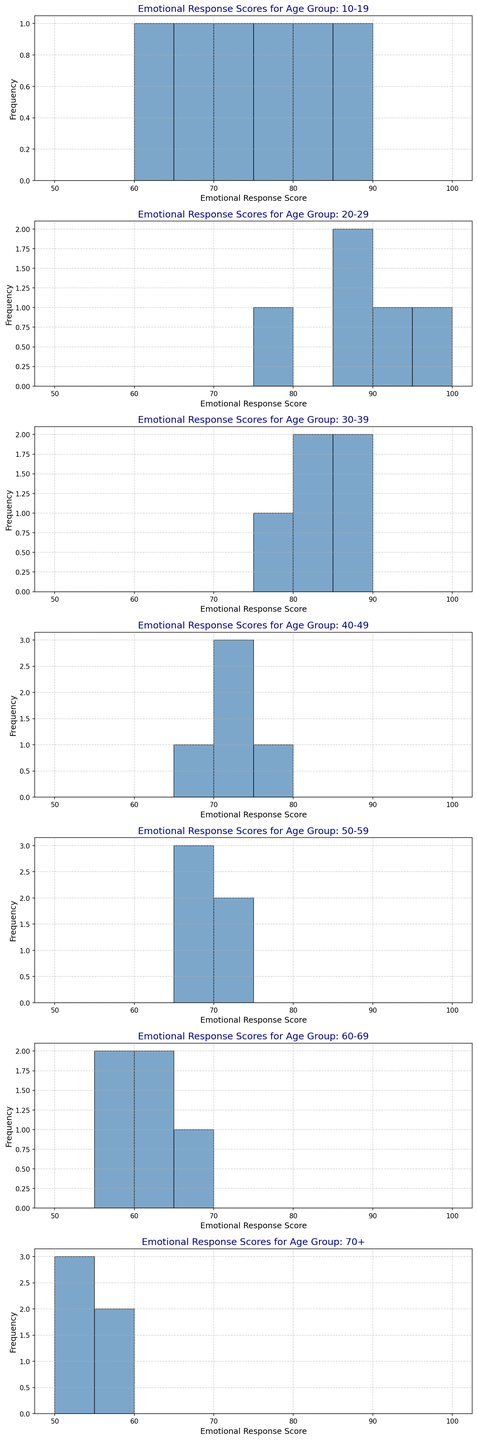Can you identify which age group has the highest peak in their histogram? Looking at the histograms, the age group 20-29 has the highest peak in frequency.
Answer: 20-29 How many age groups have their histogram peaks between the emotional response scores of 70 and 80? Checking each histogram, the age groups 10-19, 30-39, and 40-49 have their peaks between the scores of 70 and 80.
Answer: 3 Which age group shows the broadest distribution of emotional response scores in their histogram? By visual inspection, the age group 60-69 shows scores ranging from 55 to 65, which is a relatively broad range compared to others.
Answer: 60-69 For the 40-49 age group, what is the frequency of the most common emotional response score? The histogram for 40-49 shows the highest bar at the score of 72, with a frequency of more than 70.
Answer: 72 Compare the emotional response scores' concentration for the age groups 50-59 and 70+. Which group has a more spread-out score distribution? The histogram for the 50-59 group shows scores concentrated between 65 and 72, while the 70+ group shows a spread between 50 and 57. Thus, 70+ has a more spread-out distribution.
Answer: 70+ What can you deduce regarding the emotional response scores of age group 10-19 from its histogram shape? The histogram for 10-19 is relatively broad with frequencies dispersed mostly around 65, 70, 75, suggesting a wider variation in emotional responses within this group.
Answer: Wider Variation Are there any age groups where none of the emotional response scores fall below 65? Checking the histograms, the age groups 20-29 and 30-39 have no scores below 65.
Answer: 2 What is the modal emotional response score range for the age group 10-19? From the histogram, the most frequently occurring emotional response score in the age group 10-19 is around the bar that peaks at 75.
Answer: 75 Identify the age group with the lowest maximum emotional response score and mention its value. The histogram for 70+ shows that the highest emotional response score in this group is around 57.
Answer: 70+, 57 Which age group shows the highest variability in their emotional response scores? The histograms indicate that the age group 60-69 has scores ranging widely from 55 to 65, indicating the highest variability.
Answer: 60-69 